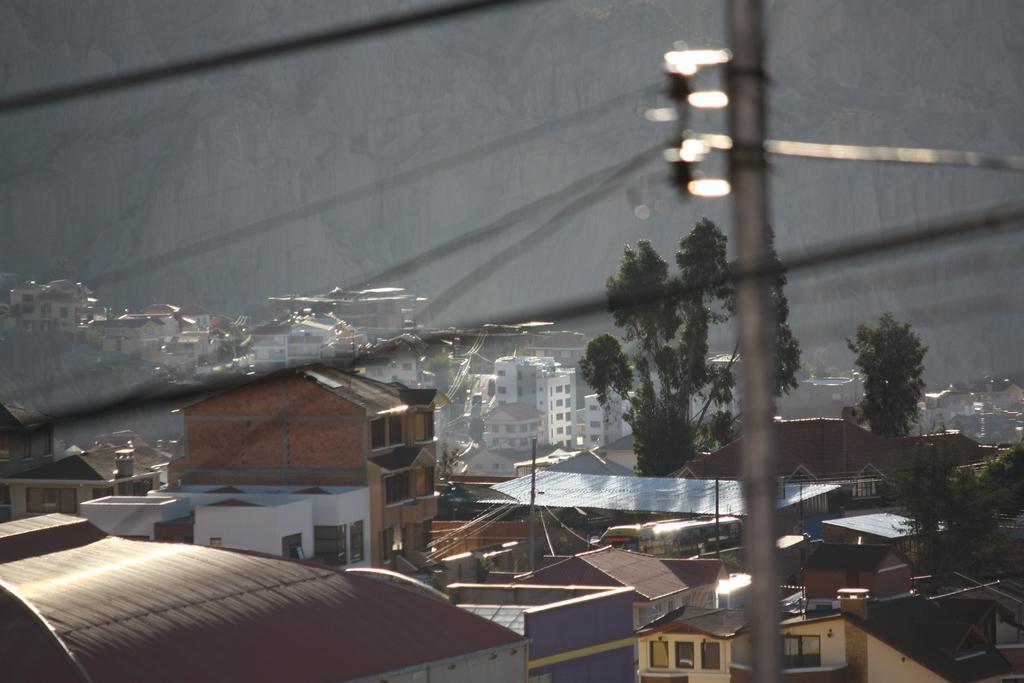Could you give a brief overview of what you see in this image? In this image we can see few buildings, poles and wires. 